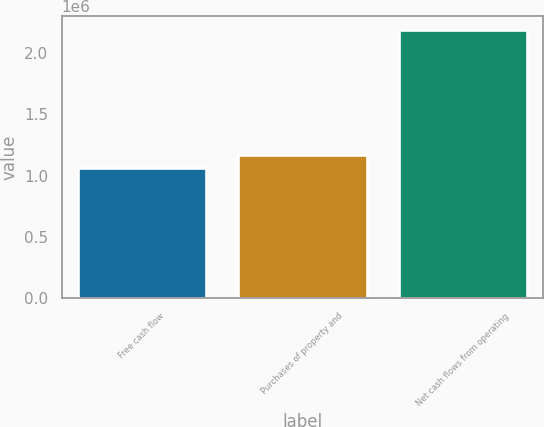Convert chart. <chart><loc_0><loc_0><loc_500><loc_500><bar_chart><fcel>Free cash flow<fcel>Purchases of property and<fcel>Net cash flows from operating<nl><fcel>1.05845e+06<fcel>1.17144e+06<fcel>2.18834e+06<nl></chart> 